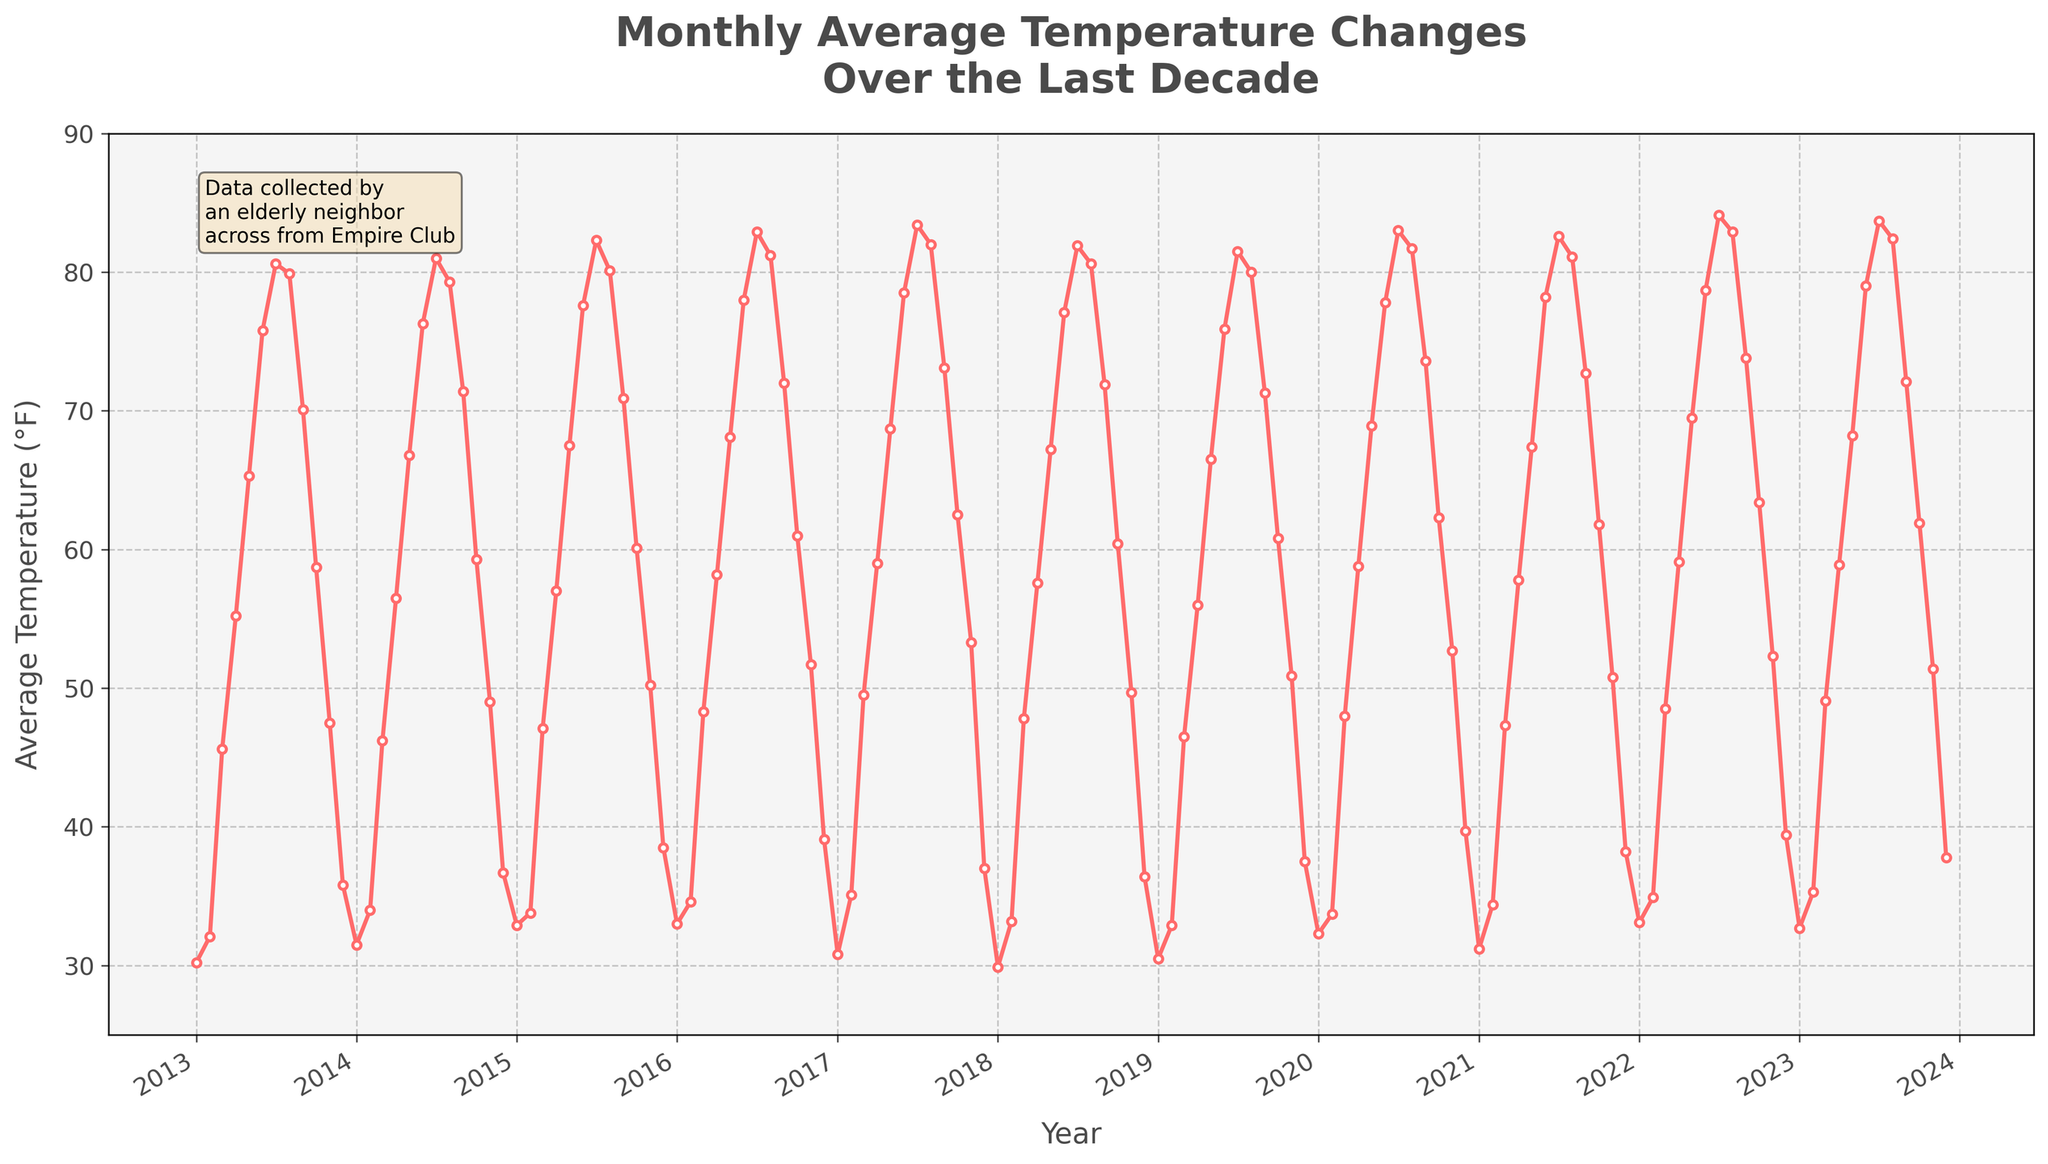What is the peak temperature recorded in July over the last decade? From the plot, find the points that represent July for each year and identify the maximum temperature among them. The peak temperature is in July 2022 with 84.1°F.
Answer: 84.1°F Which year had the lowest average temperature in January? Look at the points for January across all years and identify the one with the lowest value. January 2018 has the lowest temperature at 29.9°F.
Answer: 2018 What is the general trend of the average temperature in August from 2013 to 2023? Trace the points that correspond to August across the years and observe the pattern. The trend shows fluctuations but generally stays around 80°F with slight increases in some years.
Answer: Fluctuating around 80°F How does the average temperature in December 2023 compare to that in December 2013? Compare the December points for the years 2023 and 2013. December 2023 (37.8°F) is slightly higher than December 2013 (35.8°F).
Answer: December 2023 is higher On average, which month tends to have the highest temperature each year? Identify the month with the highest data points each year, which consistently appears to be around July.
Answer: July Over the last decade, what was the range (difference) between the highest and lowest recorded temperatures? Locate the highest peak and lowest valley in the plot. The highest is 84.1°F (July 2022) and the lowest is 29.9°F (January 2018), so the range is 84.1 - 29.9 = 54.2°F.
Answer: 54.2°F In which year did April experience its highest average temperature? Find the points for April for each year and determine the maximum. April 2022 has the highest at 59.1°F.
Answer: 2022 Which season (winter, spring, summer, or fall) shows the most variability in temperature over the decade? Examine temperature fluctuations for winter (Dec–Feb), spring (Mar–May), summer (Jun–Aug), and fall (Sep–Nov) throughout the years. Spring and summer show significant variability, with summer showing more pronounced highs and lows (e.g., July and August temperatures).
Answer: Summer What is the trend in temperature for the month of November from 2013 to 2023? Trace the points for November across the decade and observe the pattern. November temperatures generally show a slight increasing trend over the years.
Answer: Slightly increasing trend Comparing the average temperature of February 2020 with February 2014, which month was warmer and by how much? Note the temperatures for February 2020 and 2014. February 2020 is 33.7°F and February 2014 is 34.0°F. Calculate the difference: 34.0 - 33.7 = 0.3°F, so February 2014 is warmer by 0.3°F.
Answer: February 2014 by 0.3°F 